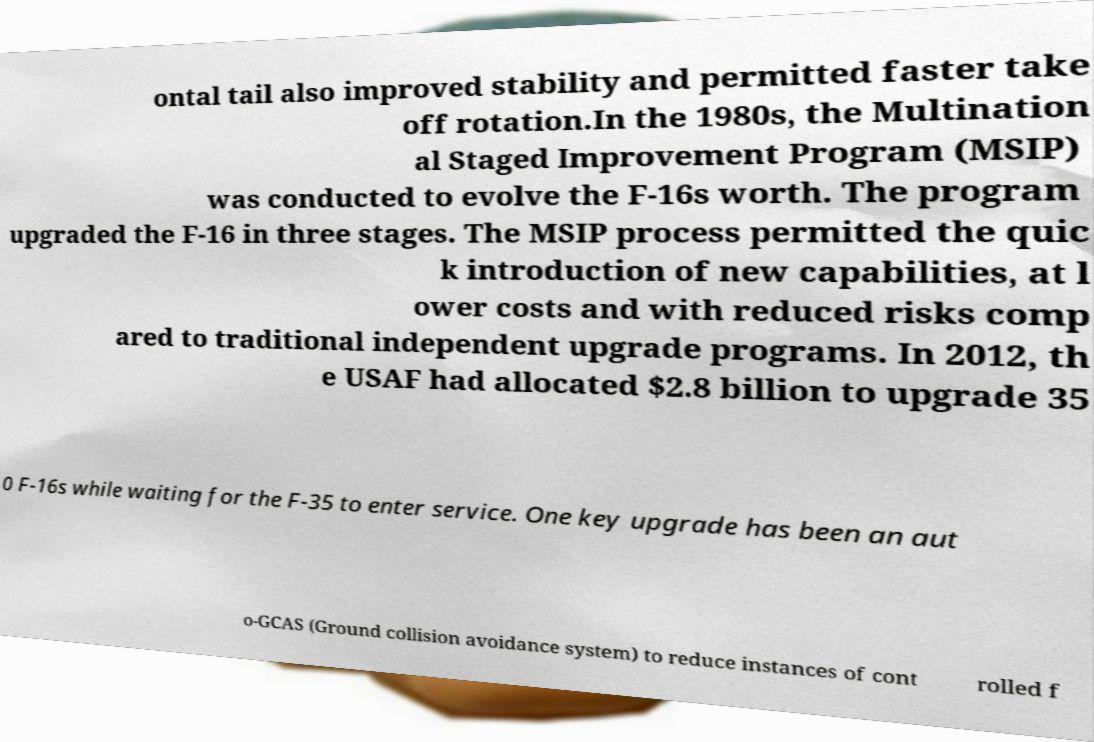Please identify and transcribe the text found in this image. ontal tail also improved stability and permitted faster take off rotation.In the 1980s, the Multination al Staged Improvement Program (MSIP) was conducted to evolve the F-16s worth. The program upgraded the F-16 in three stages. The MSIP process permitted the quic k introduction of new capabilities, at l ower costs and with reduced risks comp ared to traditional independent upgrade programs. In 2012, th e USAF had allocated $2.8 billion to upgrade 35 0 F-16s while waiting for the F-35 to enter service. One key upgrade has been an aut o-GCAS (Ground collision avoidance system) to reduce instances of cont rolled f 